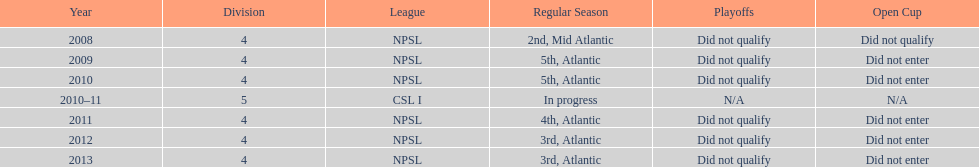During which ultimate year did they finish in 3rd place? 2013. 